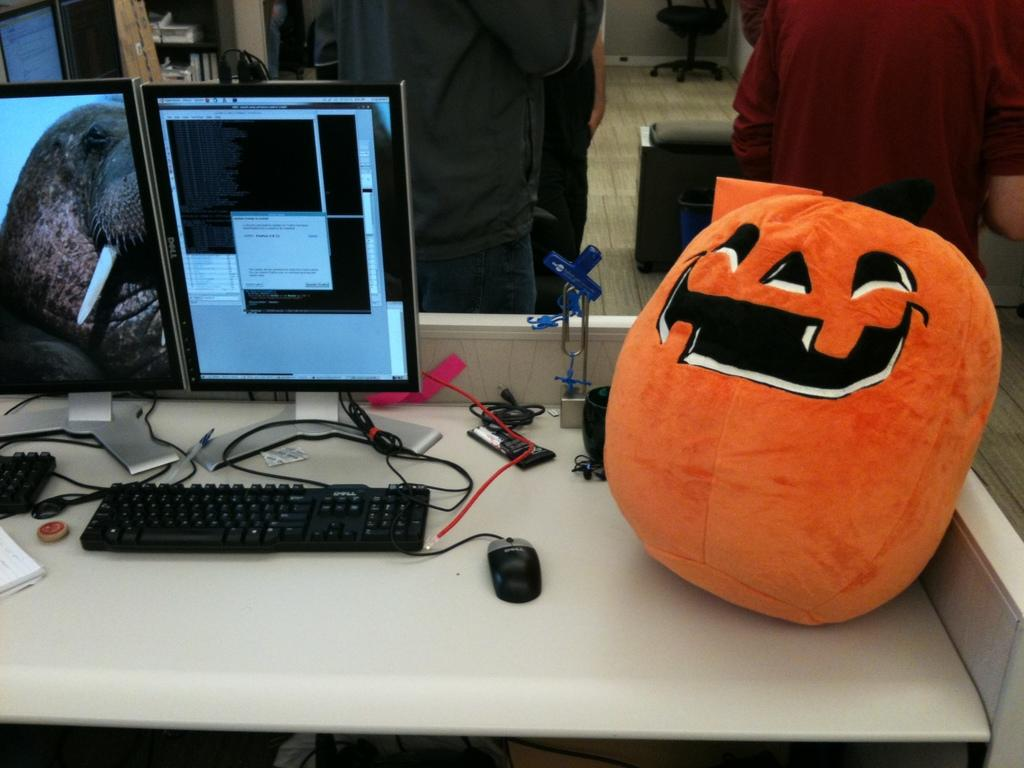What electronic devices can be seen in the image? There are monitors and keyboards in the image. What is used to interact with the monitors? There is a mouse in the image, which is used to interact with the monitors. What connects the devices in the image? Cables are visible in the image, connecting the devices. What non-electronic object is present in the image? There is a doll in the image. What is the setting of the image? There is a wall, floor, and chair in the background of the image, suggesting an indoor setting. How many people are present in the image? People are present in the image, but the exact number is not specified. What type of rifle can be seen leaning against the wall in the image? There is no rifle present in the image; only monitors, keyboards, cables, a doll, a mouse, objects on the table, people, a wall, a floor, and a chair are visible. 